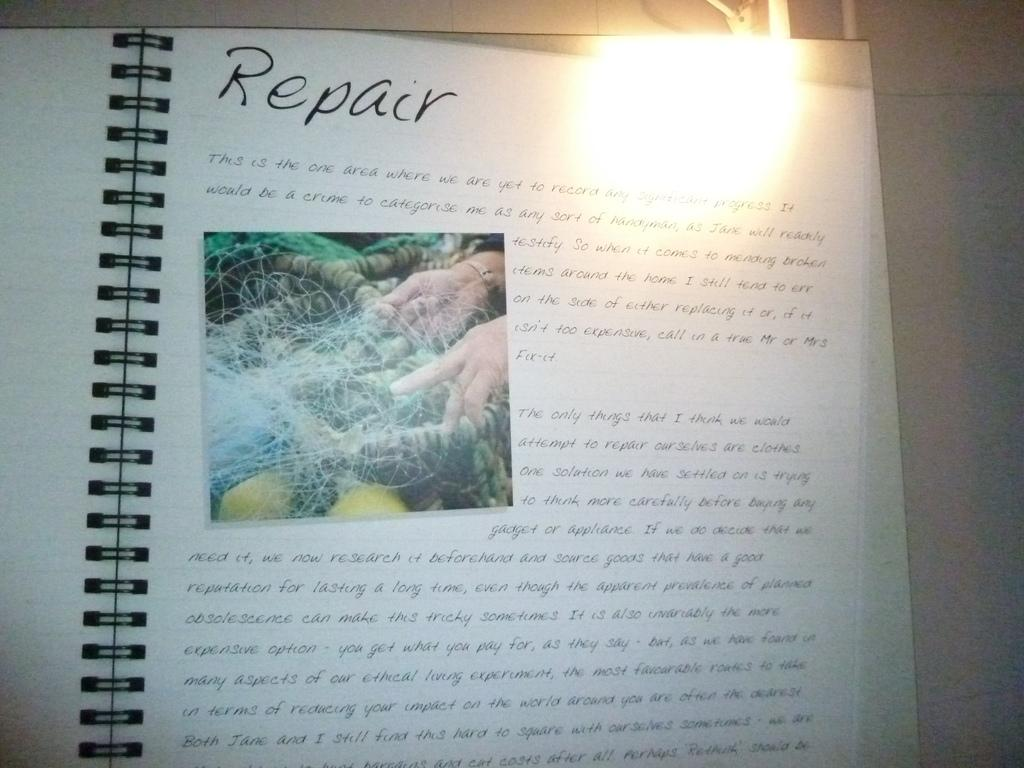<image>
Relay a brief, clear account of the picture shown. An open book with plastic spiral binding on a page titled "Repair". 